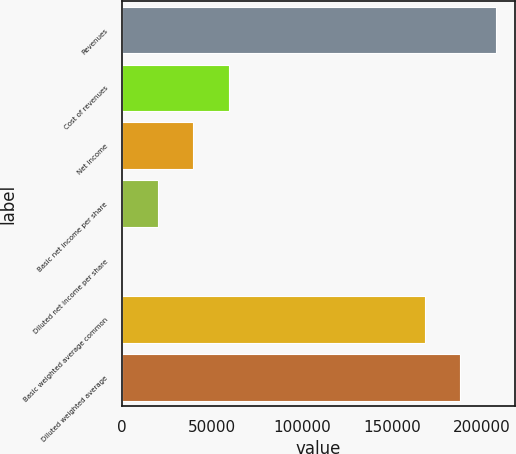Convert chart to OTSL. <chart><loc_0><loc_0><loc_500><loc_500><bar_chart><fcel>Revenues<fcel>Cost of revenues<fcel>Net income<fcel>Basic net income per share<fcel>Diluted net income per share<fcel>Basic weighted average common<fcel>Diluted weighted average<nl><fcel>207943<fcel>59204.2<fcel>39469.5<fcel>19734.9<fcel>0.18<fcel>168474<fcel>188209<nl></chart> 